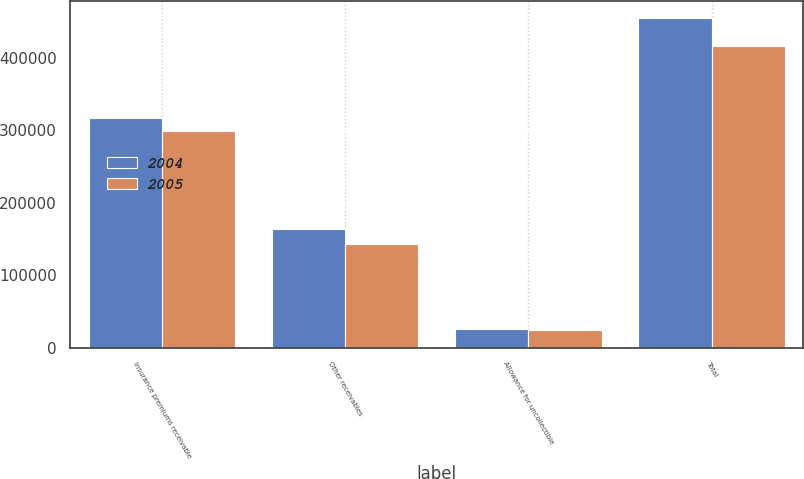Convert chart. <chart><loc_0><loc_0><loc_500><loc_500><stacked_bar_chart><ecel><fcel>Insurance premiums receivable<fcel>Other receivables<fcel>Allowance for uncollectible<fcel>Total<nl><fcel>2004<fcel>316238<fcel>163885<fcel>25334<fcel>454789<nl><fcel>2005<fcel>298271<fcel>143064<fcel>24818<fcel>416517<nl></chart> 